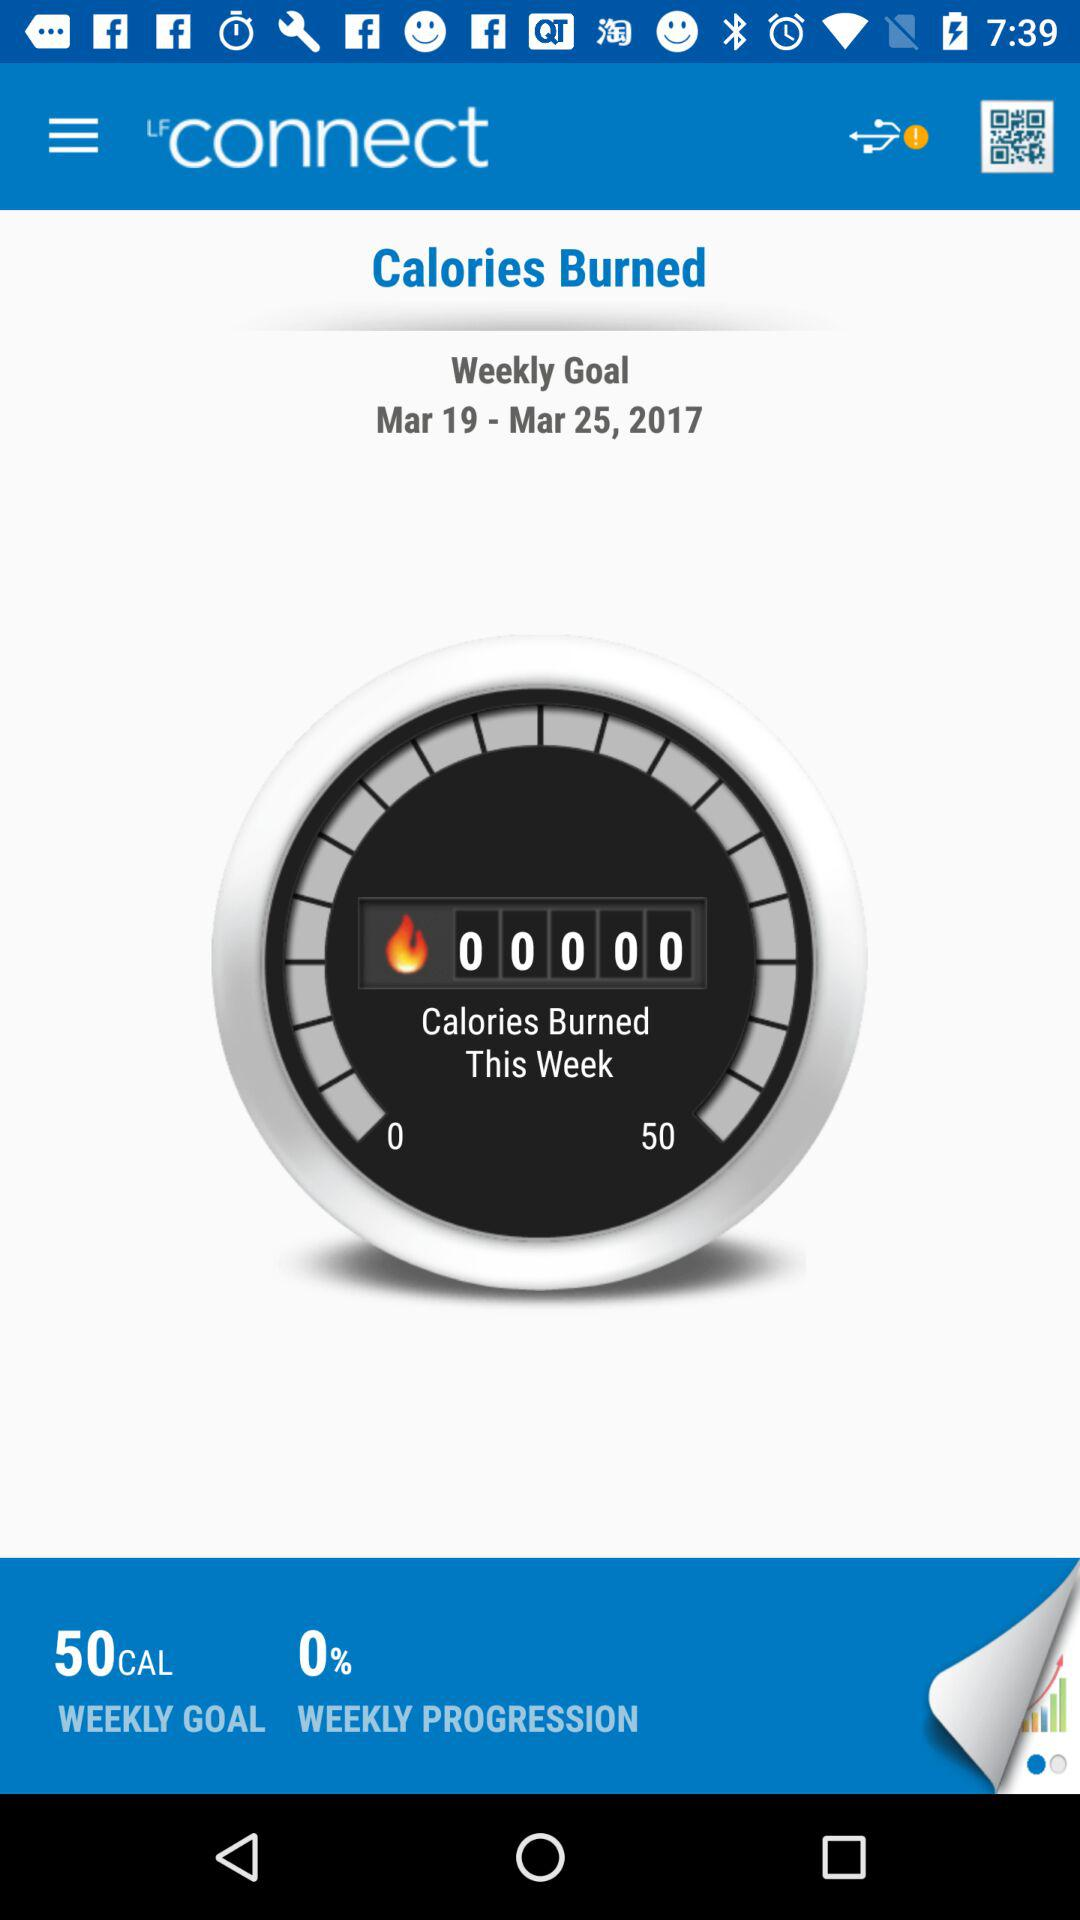What is the percentage of weekly progression? The percentage of weekly progression is 0. 